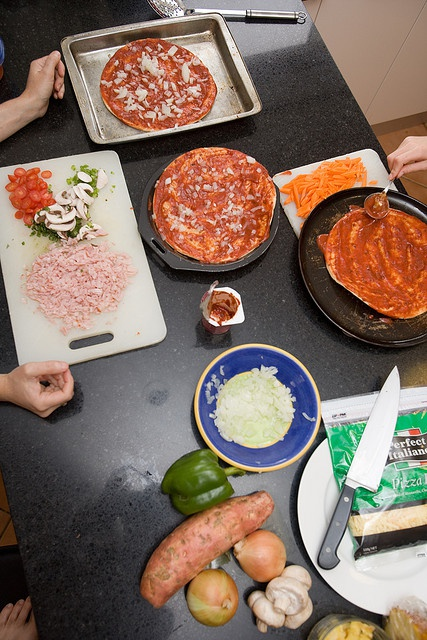Describe the objects in this image and their specific colors. I can see dining table in black, gray, lightgray, and darkgray tones, dining table in black, gray, tan, and darkgray tones, bowl in black, beige, and blue tones, pizza in black, red, salmon, brown, and lightpink tones, and pizza in black, red, brown, and salmon tones in this image. 